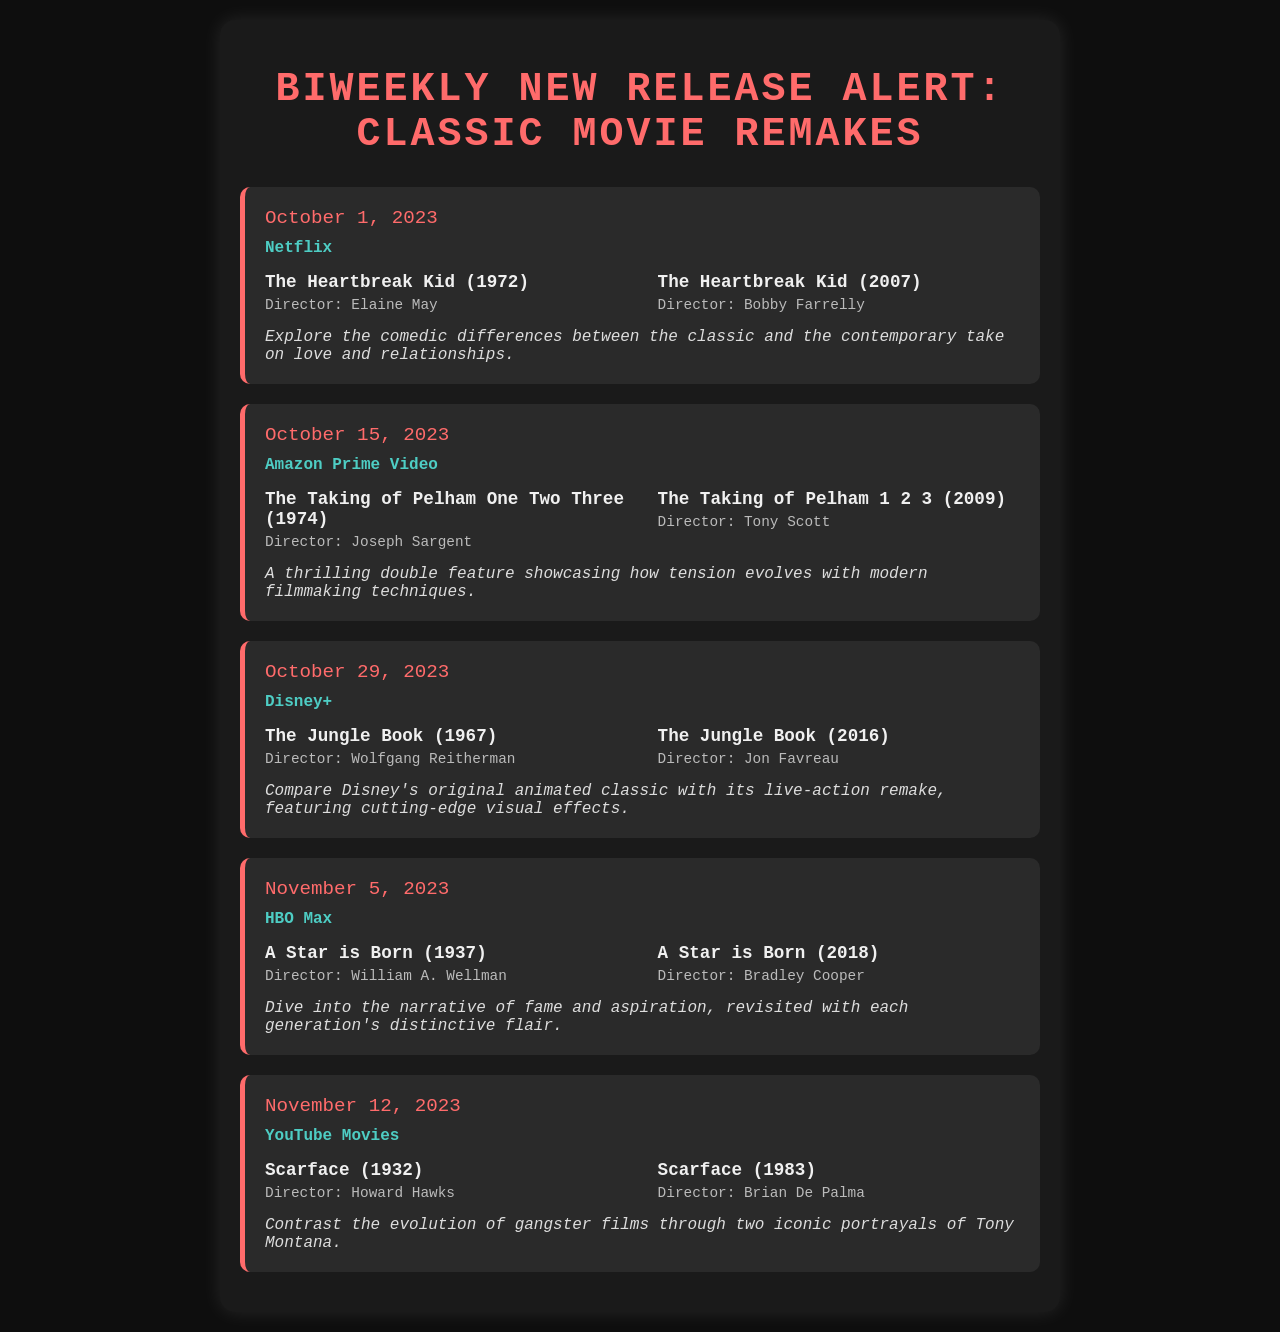What is the release date for "The Jungle Book" remake? The release date for the remake of "The Jungle Book" is mentioned in the document as October 29, 2023.
Answer: October 29, 2023 Who directed the original "Scarface"? The original "Scarface" released in 1932 was directed by Howard Hawks, as stated in the document.
Answer: Howard Hawks Which streaming platform features "A Star is Born" (2018)? The document specifies that "A Star is Born" (2018) is available on HBO Max.
Answer: HBO Max What is a notable theme explored in the comparison of "The Heartbreak Kid" films? The notes highlight the exploration of comedic differences in love and relationships between the classic and contemporary versions.
Answer: Love and relationships How many classic movie remakes are scheduled for release in this document? There are five pairs of classic movie remakes and their original versions listed in the schedule.
Answer: Five 